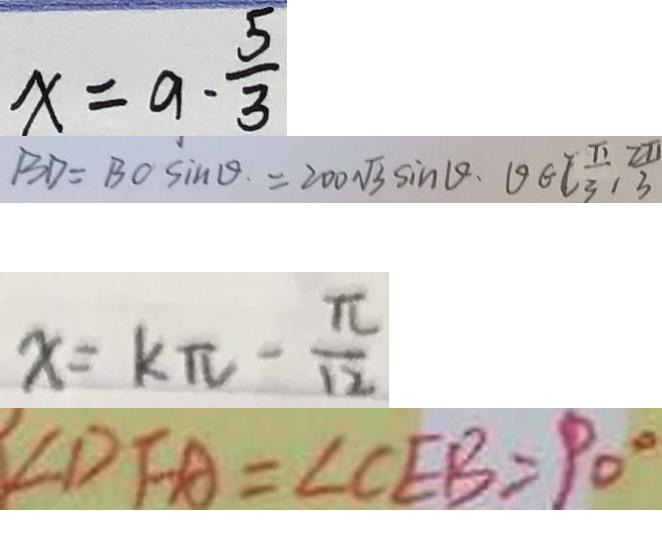<formula> <loc_0><loc_0><loc_500><loc_500>x = a \cdot \frac { 5 } { 3 } 
 B D = B O \sin \theta = 2 0 0 \sqrt { 3 } \sin \theta . \theta \epsilon [ \frac { \pi } { 3 } , \frac { 2 \pi } { 4 } 
 x = k \pi - \frac { \pi } { 1 2 } 
 \angle D F A = \angle C E B = 9 0 ^ { \circ }</formula> 